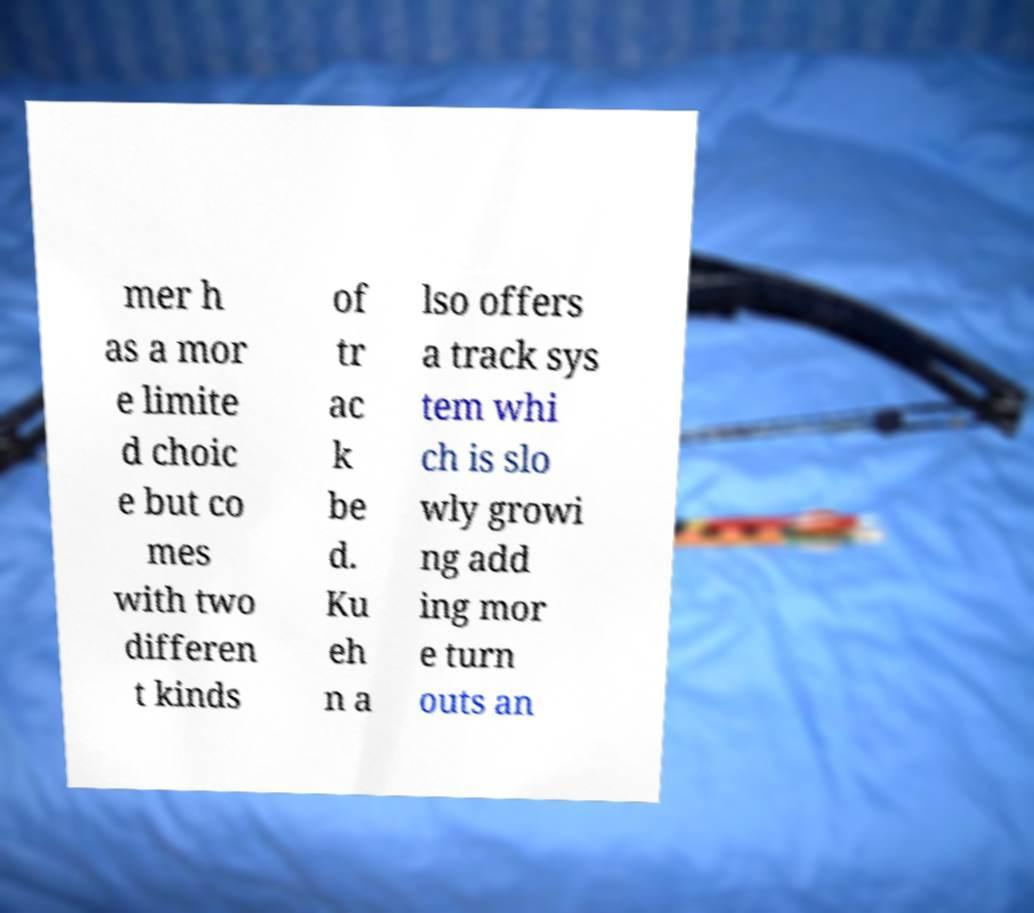Please read and relay the text visible in this image. What does it say? mer h as a mor e limite d choic e but co mes with two differen t kinds of tr ac k be d. Ku eh n a lso offers a track sys tem whi ch is slo wly growi ng add ing mor e turn outs an 